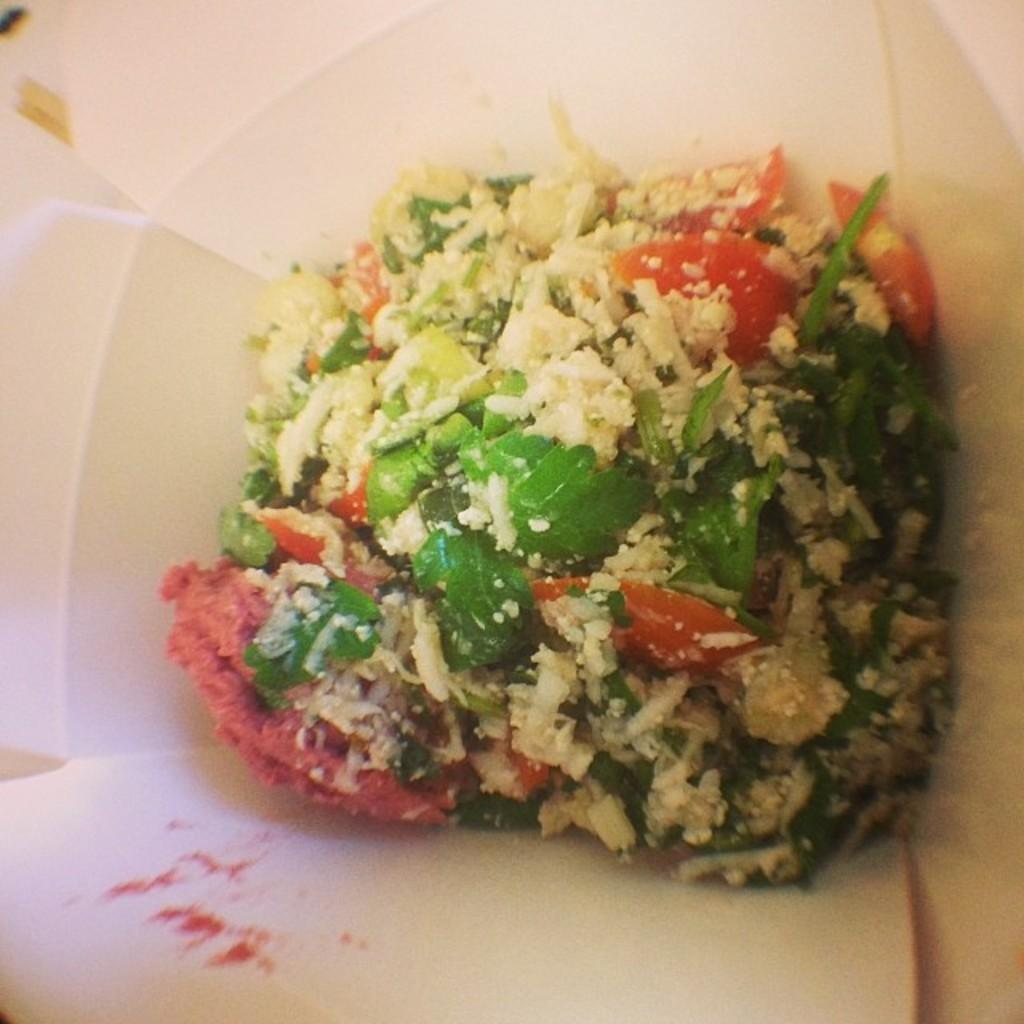What can be seen on the plate in the image? There is food on the plate in the image. Can you describe the plate itself? The facts provided only mention the presence of a plate, so we cannot describe its specific features. What type of animal can be seen drawing on the plate with chalk in the image? There is no animal or chalk present in the image; it only features a plate with food on it. 